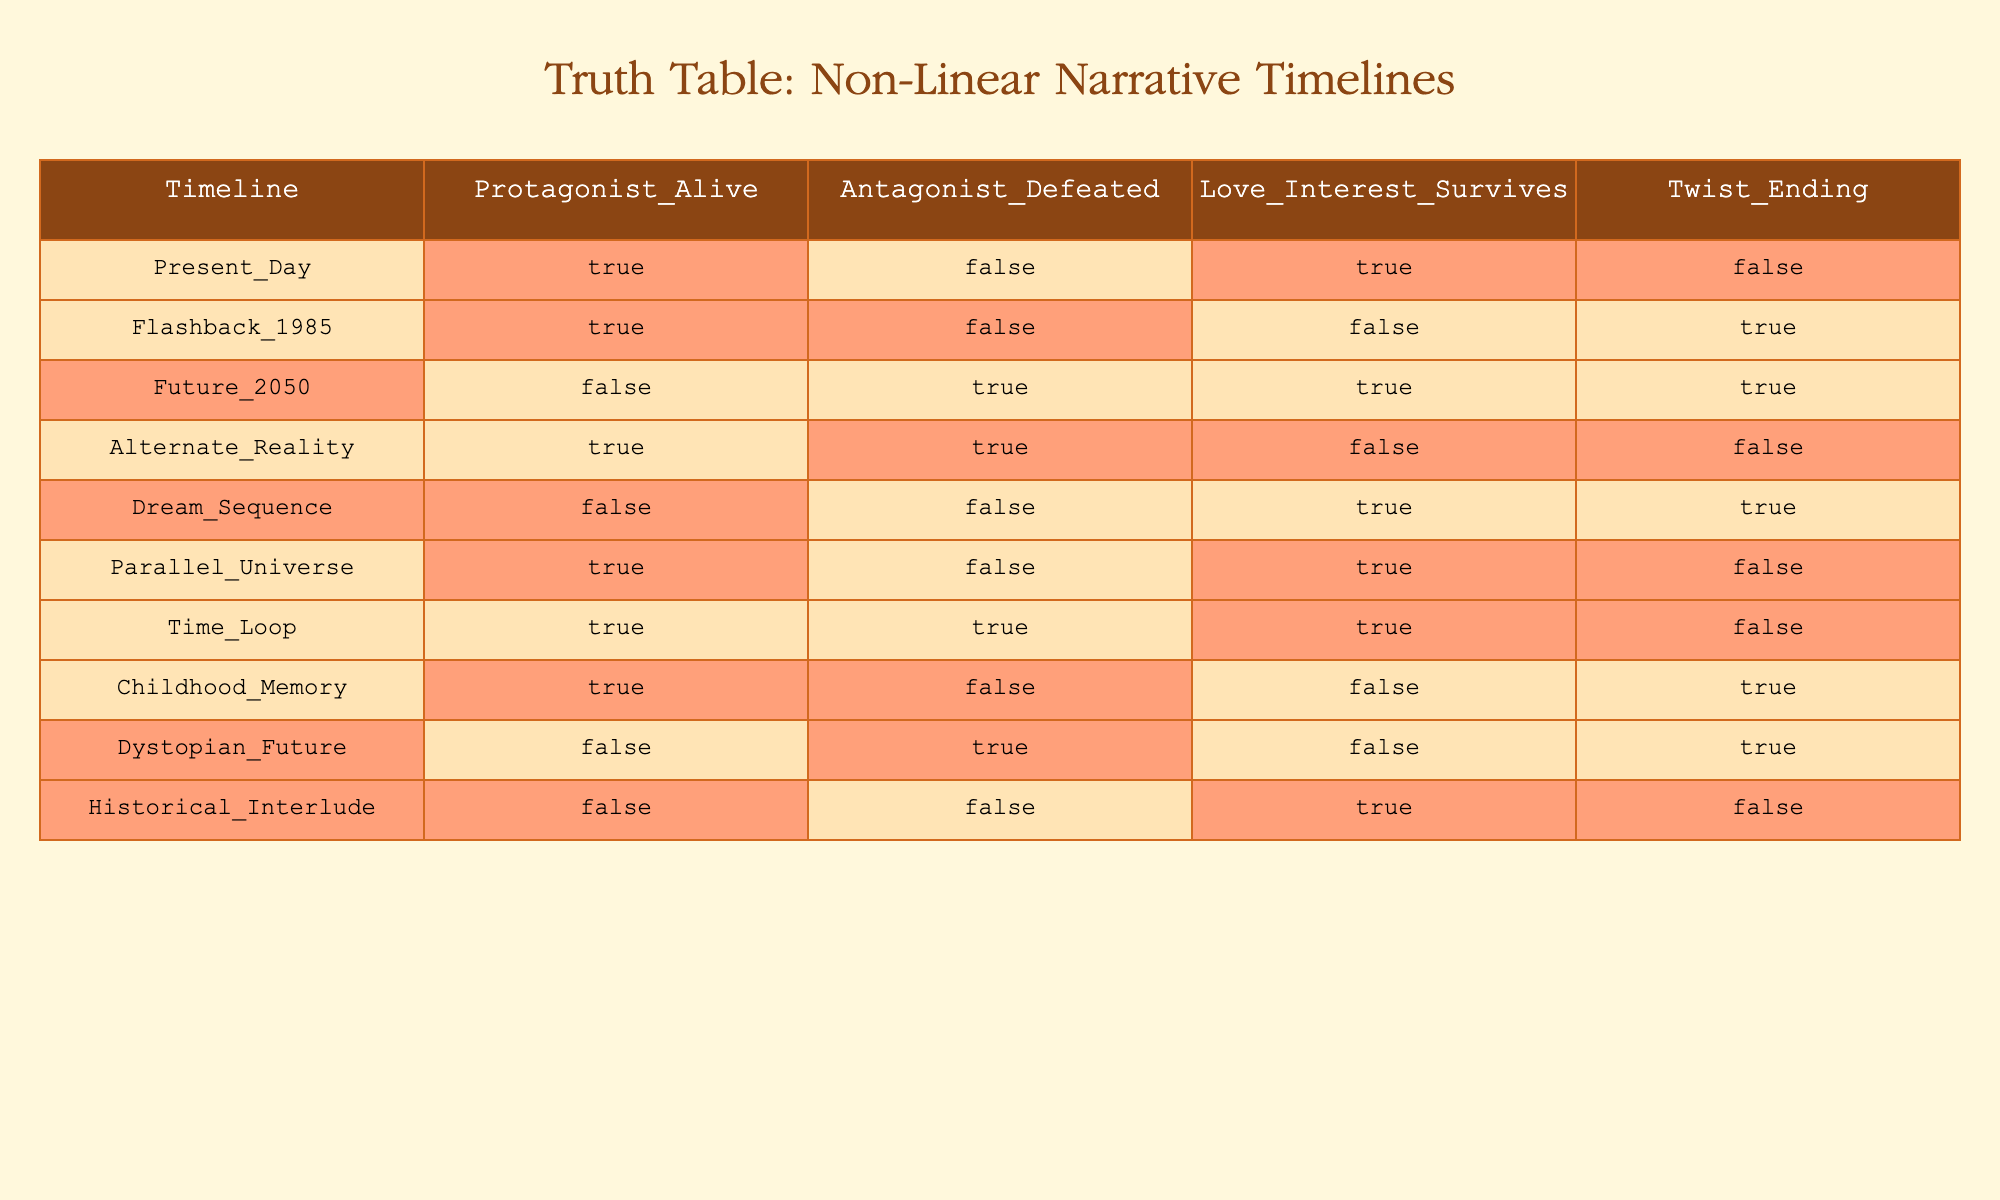What timeline has the protagonist alive and the love interest surviving? The rows that show the protagonist is alive (which is marked TRUE) and the love interest survives (also marked TRUE) are Present_Day and Parallel_Universe. Present_Day has both conditions met, while Parallel_Universe also has the protagonist alive but the love interest survives as well. However, the only timeline that meets both criteria simultaneously is Present_Day.
Answer: Present_Day In how many timelines does the antagonist get defeated? The antagonist is defeated in the timelines where Antagonist_Defeated is marked TRUE. Scanning through the table, we see that the Antagonist is defeated in Future_2050, Alternate_Reality, and Time_Loop. Counting these rows gives a total of 3 timelines where this condition holds true.
Answer: 3 Is the love interest alive in the Dream_Sequence? In the row for Dream_Sequence, we can see that Love_Interest_Survives is marked TRUE. This indicates that in this timeline, the love interest does indeed survive.
Answer: Yes Which timeline has a twist ending when the protagonist is alive? Looking for timelines where the protagonist is alive (TRUE) and Twist_Ending is also TRUE, the only timeline that fits these criteria is Flashback_1985. The absence of twist endings in other timelines like Present_Day and Time_Loop, which also have the protagonist alive, shows that Flashback_1985 is the only specific instance meeting both conditions.
Answer: Flashback_1985 How many timelines feature both the protagonist alive and the antagonist defeated? To find how many timelines have both the protagonist alive and the antagonist defeated, we review all rows where Protagonist_Alive is TRUE and Antagonist_Defeated is also TRUE. The timelines that fit this requirement are Time_Loop and Alternate_Reality, giving us a count of 2 such timelines.
Answer: 2 What is the total number of timelines where the love interest survives? To determine how many timelines have the love interest surviving, we count the rows with Love_Interest_Survives marked TRUE. These timelines include Present_Day, Future_2050, Dream_Sequence, and Historical_Interlude. Counting these yields a total of 4 timelines where the love interest survives.
Answer: 4 Does the Dystopian_Future feature the protagonist alive? In the Dystopian_Future row, we see that Protagonist_Alive has a value of FALSE. This indicates that in this timeline, the protagonist is not alive.
Answer: No Identify the years in which the timeline has no antagonist defeated but features a twist ending. We need to find timelines with Antagonist_Defeated marked FALSE and Twist_Ending marked TRUE. By reviewing the table, we see that Flashback_1985, Dream_Sequence, and Historical_Interlude fit this criterion. Since these do not contain any antagonists being defeated, the timeline years are 1985 and no specific year for the Dream_Sequence and Historical_Interlude, since they are not time-specific. Therefore, the answer is based on the available data.
Answer: 1985, Dream_Sequence, Historical_Interlude 